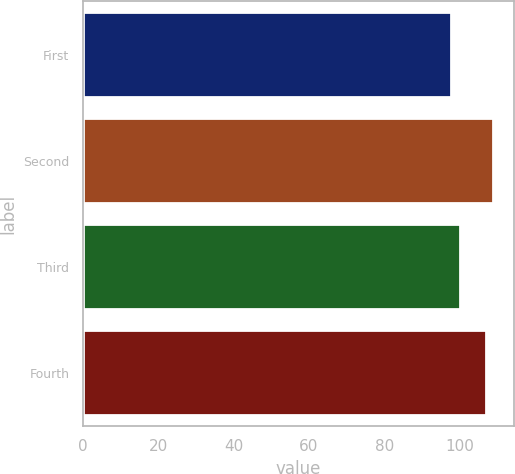Convert chart to OTSL. <chart><loc_0><loc_0><loc_500><loc_500><bar_chart><fcel>First<fcel>Second<fcel>Third<fcel>Fourth<nl><fcel>97.59<fcel>108.82<fcel>100.02<fcel>106.91<nl></chart> 